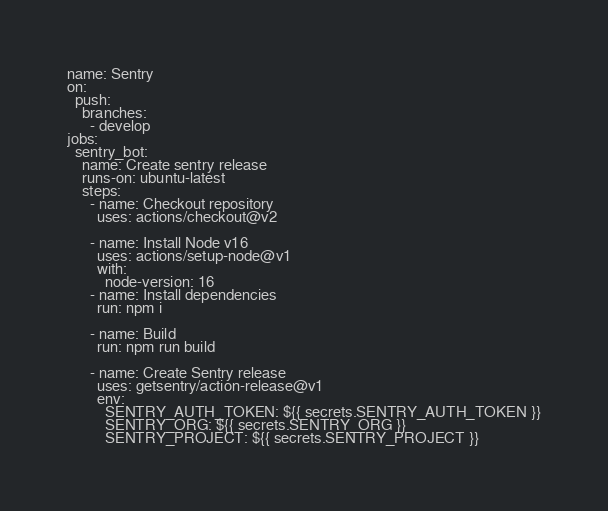Convert code to text. <code><loc_0><loc_0><loc_500><loc_500><_YAML_>name: Sentry
on:
  push:
    branches:
      - develop
jobs:
  sentry_bot:
    name: Create sentry release
    runs-on: ubuntu-latest
    steps:
      - name: Checkout repository
        uses: actions/checkout@v2

      - name: Install Node v16
        uses: actions/setup-node@v1
        with:
          node-version: 16
      - name: Install dependencies
        run: npm i

      - name: Build
        run: npm run build

      - name: Create Sentry release
        uses: getsentry/action-release@v1
        env:
          SENTRY_AUTH_TOKEN: ${{ secrets.SENTRY_AUTH_TOKEN }}
          SENTRY_ORG: ${{ secrets.SENTRY_ORG }}
          SENTRY_PROJECT: ${{ secrets.SENTRY_PROJECT }}</code> 